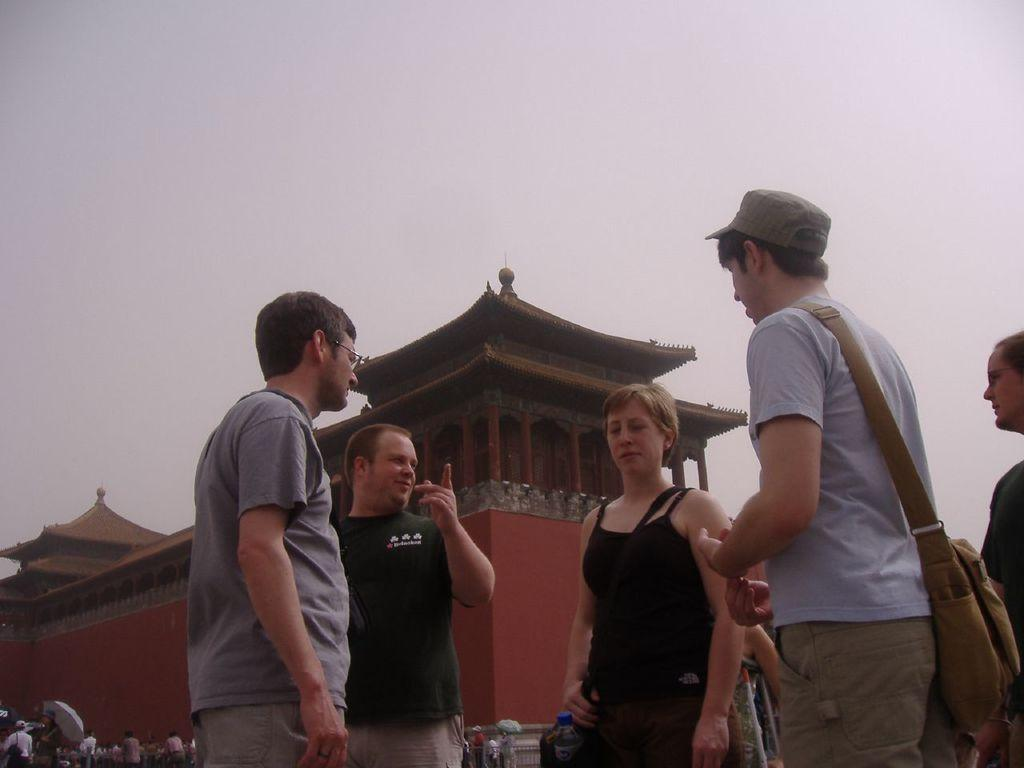How many people are in the image? There is a group of people in the image. What are two of the people doing in the image? Two persons are holding umbrellas in the image. What type of building can be seen in the image? The building in the image resembles a Chinese building. What can be seen in the background of the image? The sky is visible in the background of the image. How many babies are visible in the image? There is no mention of babies in the image; it features a group of people holding umbrellas near a Chinese-style building. What color is the shirt worn by the person in the image? The provided facts do not mention any specific clothing items or colors, so it is impossible to determine the color of any shirt in the image. 